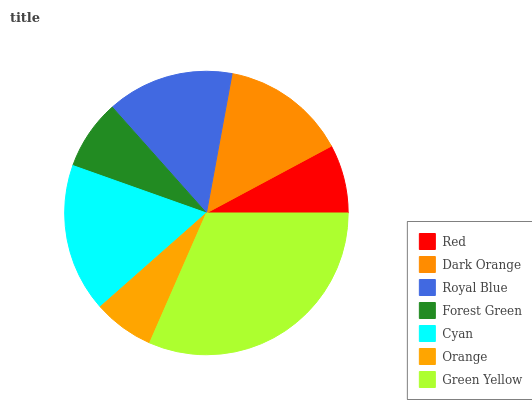Is Orange the minimum?
Answer yes or no. Yes. Is Green Yellow the maximum?
Answer yes or no. Yes. Is Dark Orange the minimum?
Answer yes or no. No. Is Dark Orange the maximum?
Answer yes or no. No. Is Dark Orange greater than Red?
Answer yes or no. Yes. Is Red less than Dark Orange?
Answer yes or no. Yes. Is Red greater than Dark Orange?
Answer yes or no. No. Is Dark Orange less than Red?
Answer yes or no. No. Is Dark Orange the high median?
Answer yes or no. Yes. Is Dark Orange the low median?
Answer yes or no. Yes. Is Green Yellow the high median?
Answer yes or no. No. Is Cyan the low median?
Answer yes or no. No. 